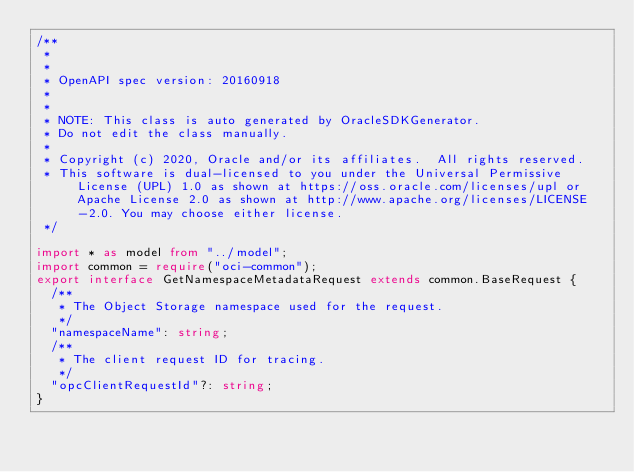Convert code to text. <code><loc_0><loc_0><loc_500><loc_500><_TypeScript_>/**
 *
 *
 * OpenAPI spec version: 20160918
 *
 *
 * NOTE: This class is auto generated by OracleSDKGenerator.
 * Do not edit the class manually.
 *
 * Copyright (c) 2020, Oracle and/or its affiliates.  All rights reserved.
 * This software is dual-licensed to you under the Universal Permissive License (UPL) 1.0 as shown at https://oss.oracle.com/licenses/upl or Apache License 2.0 as shown at http://www.apache.org/licenses/LICENSE-2.0. You may choose either license.
 */

import * as model from "../model";
import common = require("oci-common");
export interface GetNamespaceMetadataRequest extends common.BaseRequest {
  /**
   * The Object Storage namespace used for the request.
   */
  "namespaceName": string;
  /**
   * The client request ID for tracing.
   */
  "opcClientRequestId"?: string;
}
</code> 